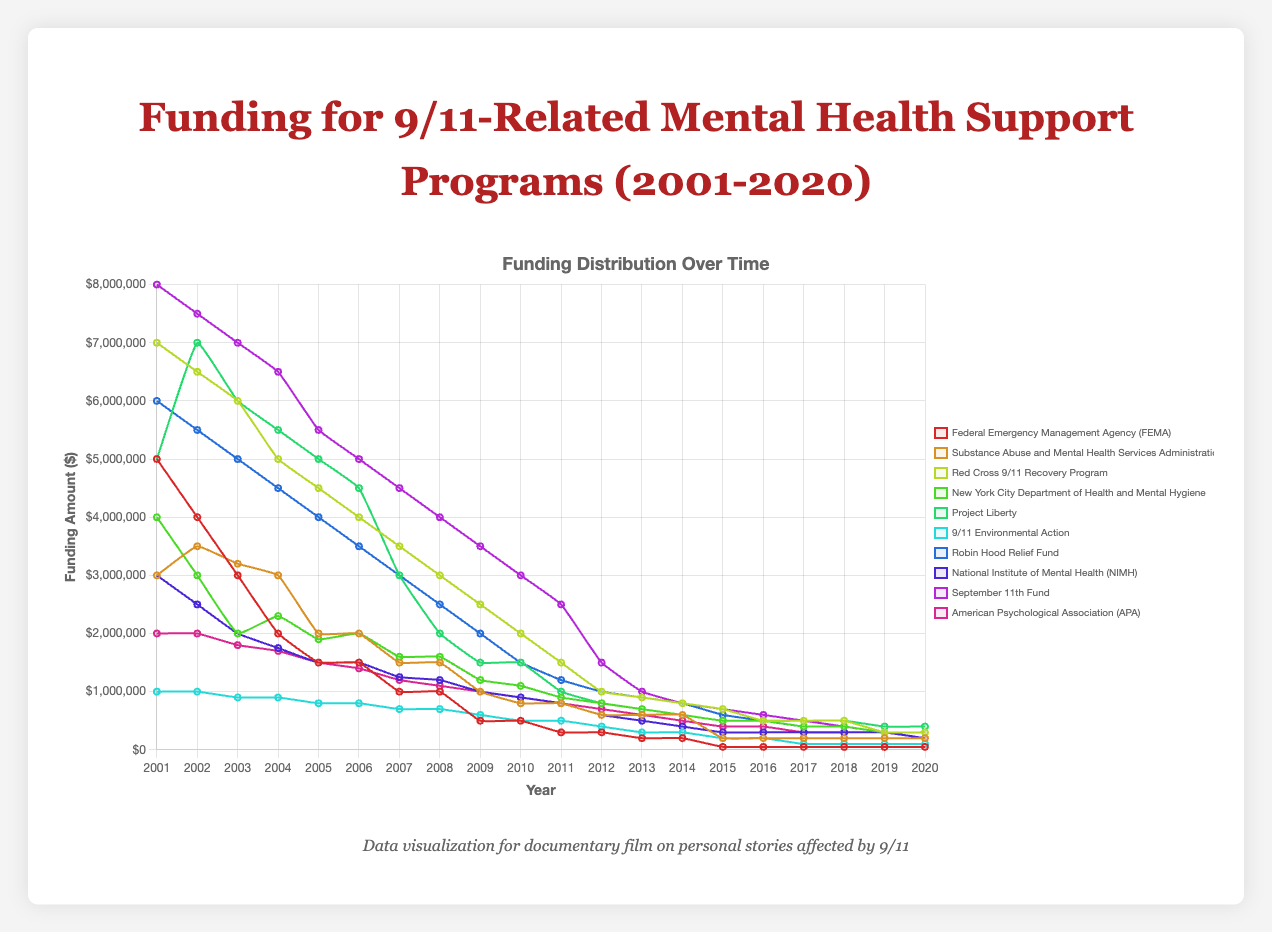What is the total funding provided by FEMA from 2001 to 2020? Sum the values for FEMA from 2001 to 2020: 5000000 + 4000000 + 3000000 + 2000000 + 1500000 + 1500000 + 1000000 + 1000000 + 500000 + 500000 + 300000 + 300000 + 200000 + 200000 + 50000 + 50000 + 50000 + 50000 + 50000 + 50000 = 23500000
Answer: 23,500,000 Which organization has the highest funding in 2001? Compare the funding values for all organizations in 2001: FEMA (5000000), SAMHSA (3000000), Red Cross (7000000), NYC Health (4000000), Project Liberty (5000000), 9/11 Environmental Action (1000000), Robin Hood Relief Fund (6000000), NIMH (3000000), September 11th Fund (8000000), APA (2000000). The highest value is 8000000 for September 11th Fund
Answer: September 11th Fund How did the funding trend for Project Liberty change from 2001 to 2020? Observe the funding values for Project Liberty over the years: 5000000, 7000000, 6000000, 5500000, 5000000, 4500000, 3000000, 2000000, 1500000, 1500000, 1000000, 800000, 700000, 600000, 500000, 500000, 500000, 500000, 400000, 400000. It started high, peaked in 2002, then generally decreased over time
Answer: Decreased overall Which two organizations have the same funding amount in 2010? Compare the funding values for all organizations in 2010: FEMA (500000), SAMHSA (800000), Red Cross (2000000), NYC Health (1100000), Project Liberty (1500000), 9/11 Environmental Action (500000), Robin Hood Fund (1500000), NIMH (900000), September 11th Fund (3000000), APA (900000). Both 9/11 Environmental Action and FEMA are 500000
Answer: FEMA and 9/11 Environmental Action What was the average funding provided by SAMHSA in the first five years (2001-2005)? The funding values for SAMHSA from 2001 to 2005 are: 3000000, 3500000, 3200000, 3000000, 2000000. Sum them: 3000000 + 3500000 + 3200000 + 3000000 + 2000000 = 14700000; then divide by 5: 14700000 / 5 = 2940000
Answer: 2,940,000 In which year did the New York City Department of Health and Mental Hygiene receive the highest funding? Compare the funding values for NYC Health over the years to find the maximum: 4000000, 3000000, 2000000, 2300000, 1900000, 2000000, 1600000, 1600000, 1200000, 1100000, 900000, 800000, 700000, 600000, 500000, 500000, 400000, 400000, 300000, 300000. The highest value is 4000000 in 2001
Answer: 2001 Between 2010 and 2020, which organization had the most consistent funding (least variation)? To determine consistency, examine the dataset for each organization from 2010 to 2020 and calculate the standard deviation for each. The organization with the smallest standard deviation has the most consistent funding. For example, without calculating exact values, visually identify organizations like FEMA, SAMHSA, and 9/11 Environmental Action to have seen limited fluctuations
Answer: 9/11 Environmental Action Which organization received more funding in 2008, Project Liberty or Robin Hood Relief Fund? Compare the funding values for Project Liberty (2000000) and Robin Hood Relief Fund (2500000) in 2008
Answer: Robin Hood Relief Fund 